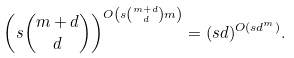Convert formula to latex. <formula><loc_0><loc_0><loc_500><loc_500>\left ( s { m + d \choose d } \right ) ^ { O \left ( s { m + d \choose d } m \right ) } = ( s d ) ^ { O ( s d ^ { m } ) } .</formula> 